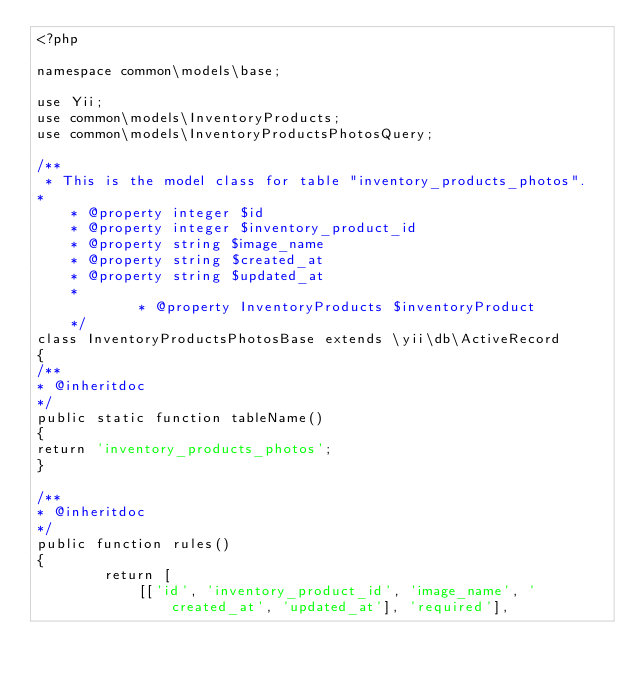<code> <loc_0><loc_0><loc_500><loc_500><_PHP_><?php

namespace common\models\base;

use Yii;
use common\models\InventoryProducts;
use common\models\InventoryProductsPhotosQuery;

/**
 * This is the model class for table "inventory_products_photos".
*
    * @property integer $id
    * @property integer $inventory_product_id
    * @property string $image_name
    * @property string $created_at
    * @property string $updated_at
    *
            * @property InventoryProducts $inventoryProduct
    */
class InventoryProductsPhotosBase extends \yii\db\ActiveRecord
{
/**
* @inheritdoc
*/
public static function tableName()
{
return 'inventory_products_photos';
}

/**
* @inheritdoc
*/
public function rules()
{
        return [
            [['id', 'inventory_product_id', 'image_name', 'created_at', 'updated_at'], 'required'],</code> 